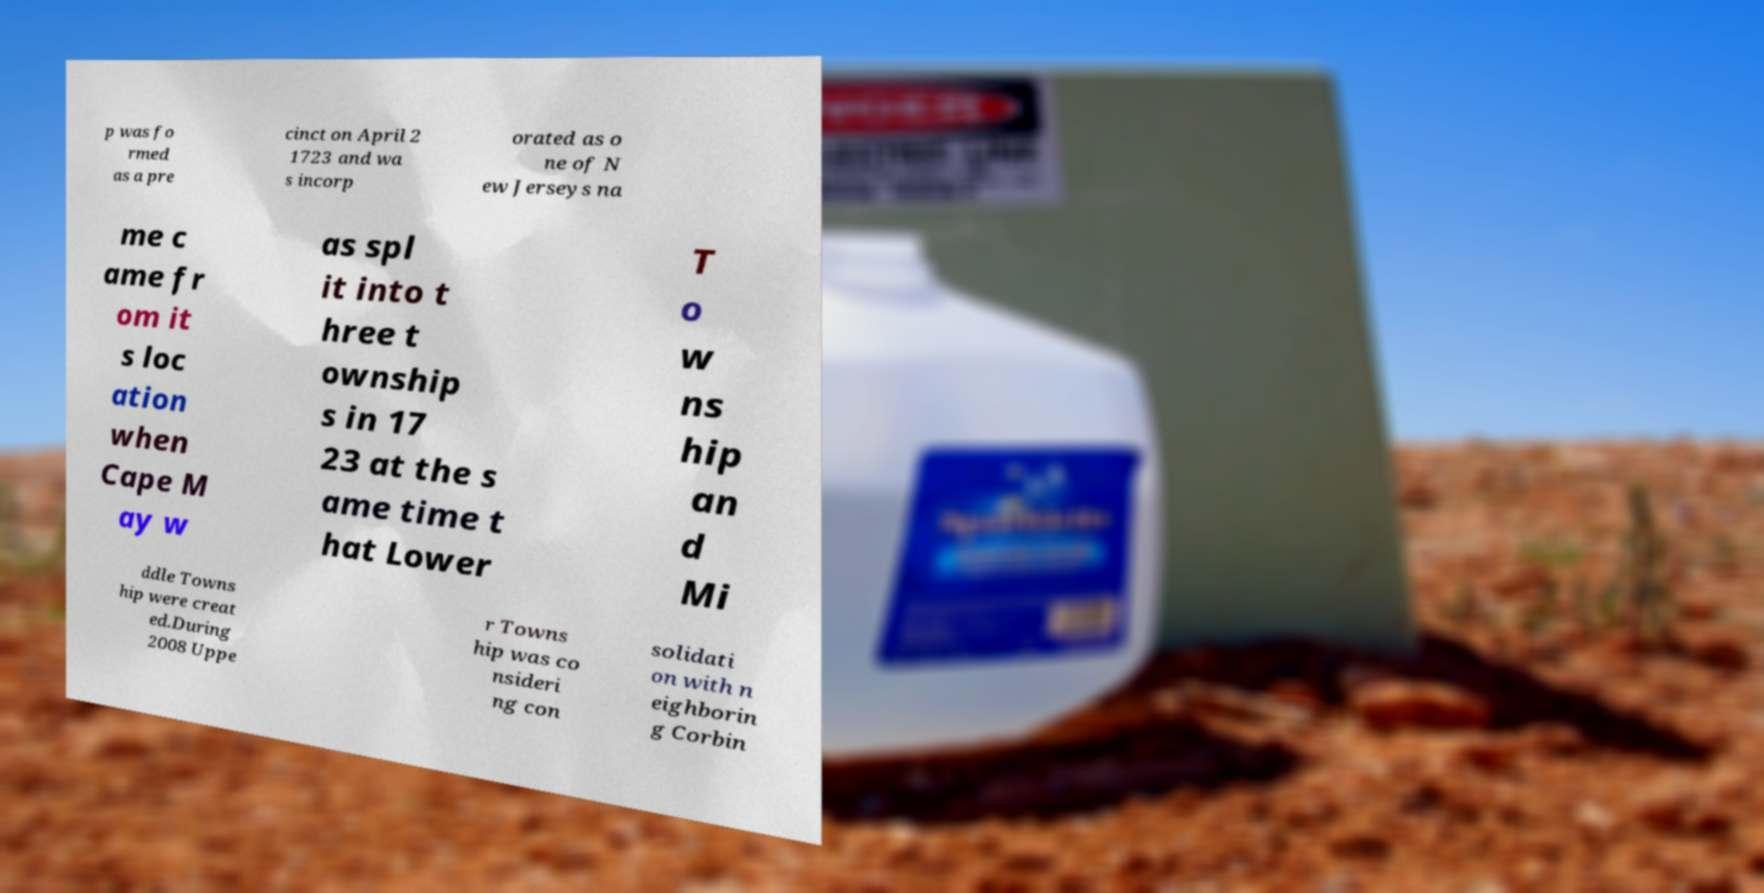Could you assist in decoding the text presented in this image and type it out clearly? p was fo rmed as a pre cinct on April 2 1723 and wa s incorp orated as o ne of N ew Jerseys na me c ame fr om it s loc ation when Cape M ay w as spl it into t hree t ownship s in 17 23 at the s ame time t hat Lower T o w ns hip an d Mi ddle Towns hip were creat ed.During 2008 Uppe r Towns hip was co nsideri ng con solidati on with n eighborin g Corbin 